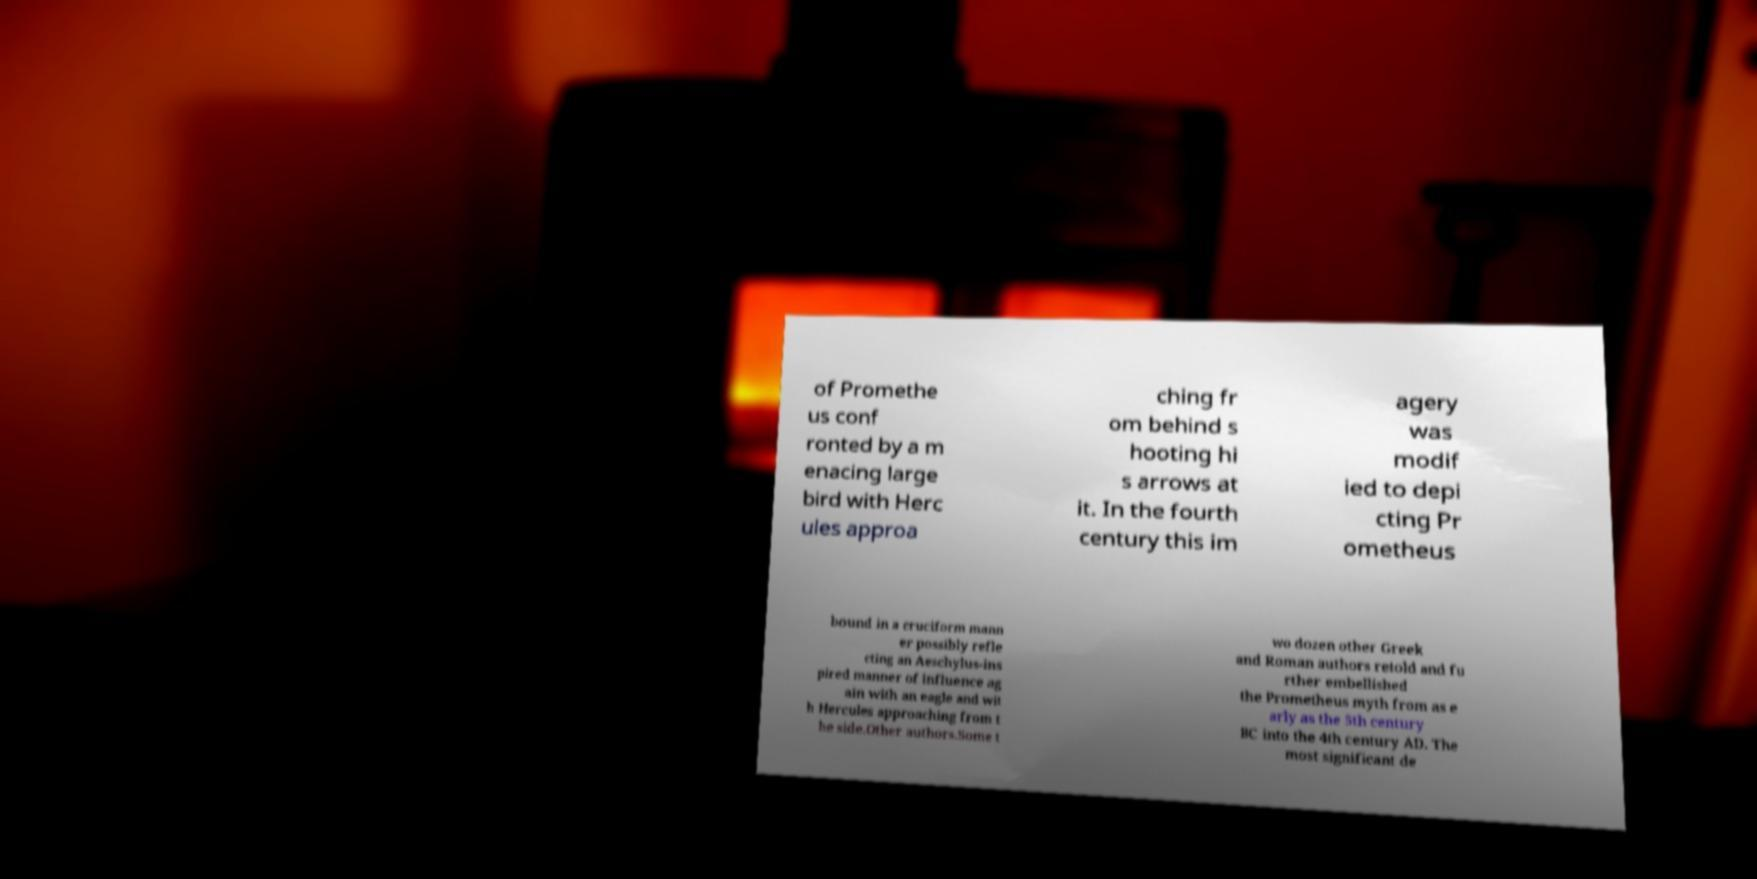Can you accurately transcribe the text from the provided image for me? of Promethe us conf ronted by a m enacing large bird with Herc ules approa ching fr om behind s hooting hi s arrows at it. In the fourth century this im agery was modif ied to depi cting Pr ometheus bound in a cruciform mann er possibly refle cting an Aeschylus-ins pired manner of influence ag ain with an eagle and wit h Hercules approaching from t he side.Other authors.Some t wo dozen other Greek and Roman authors retold and fu rther embellished the Prometheus myth from as e arly as the 5th century BC into the 4th century AD. The most significant de 